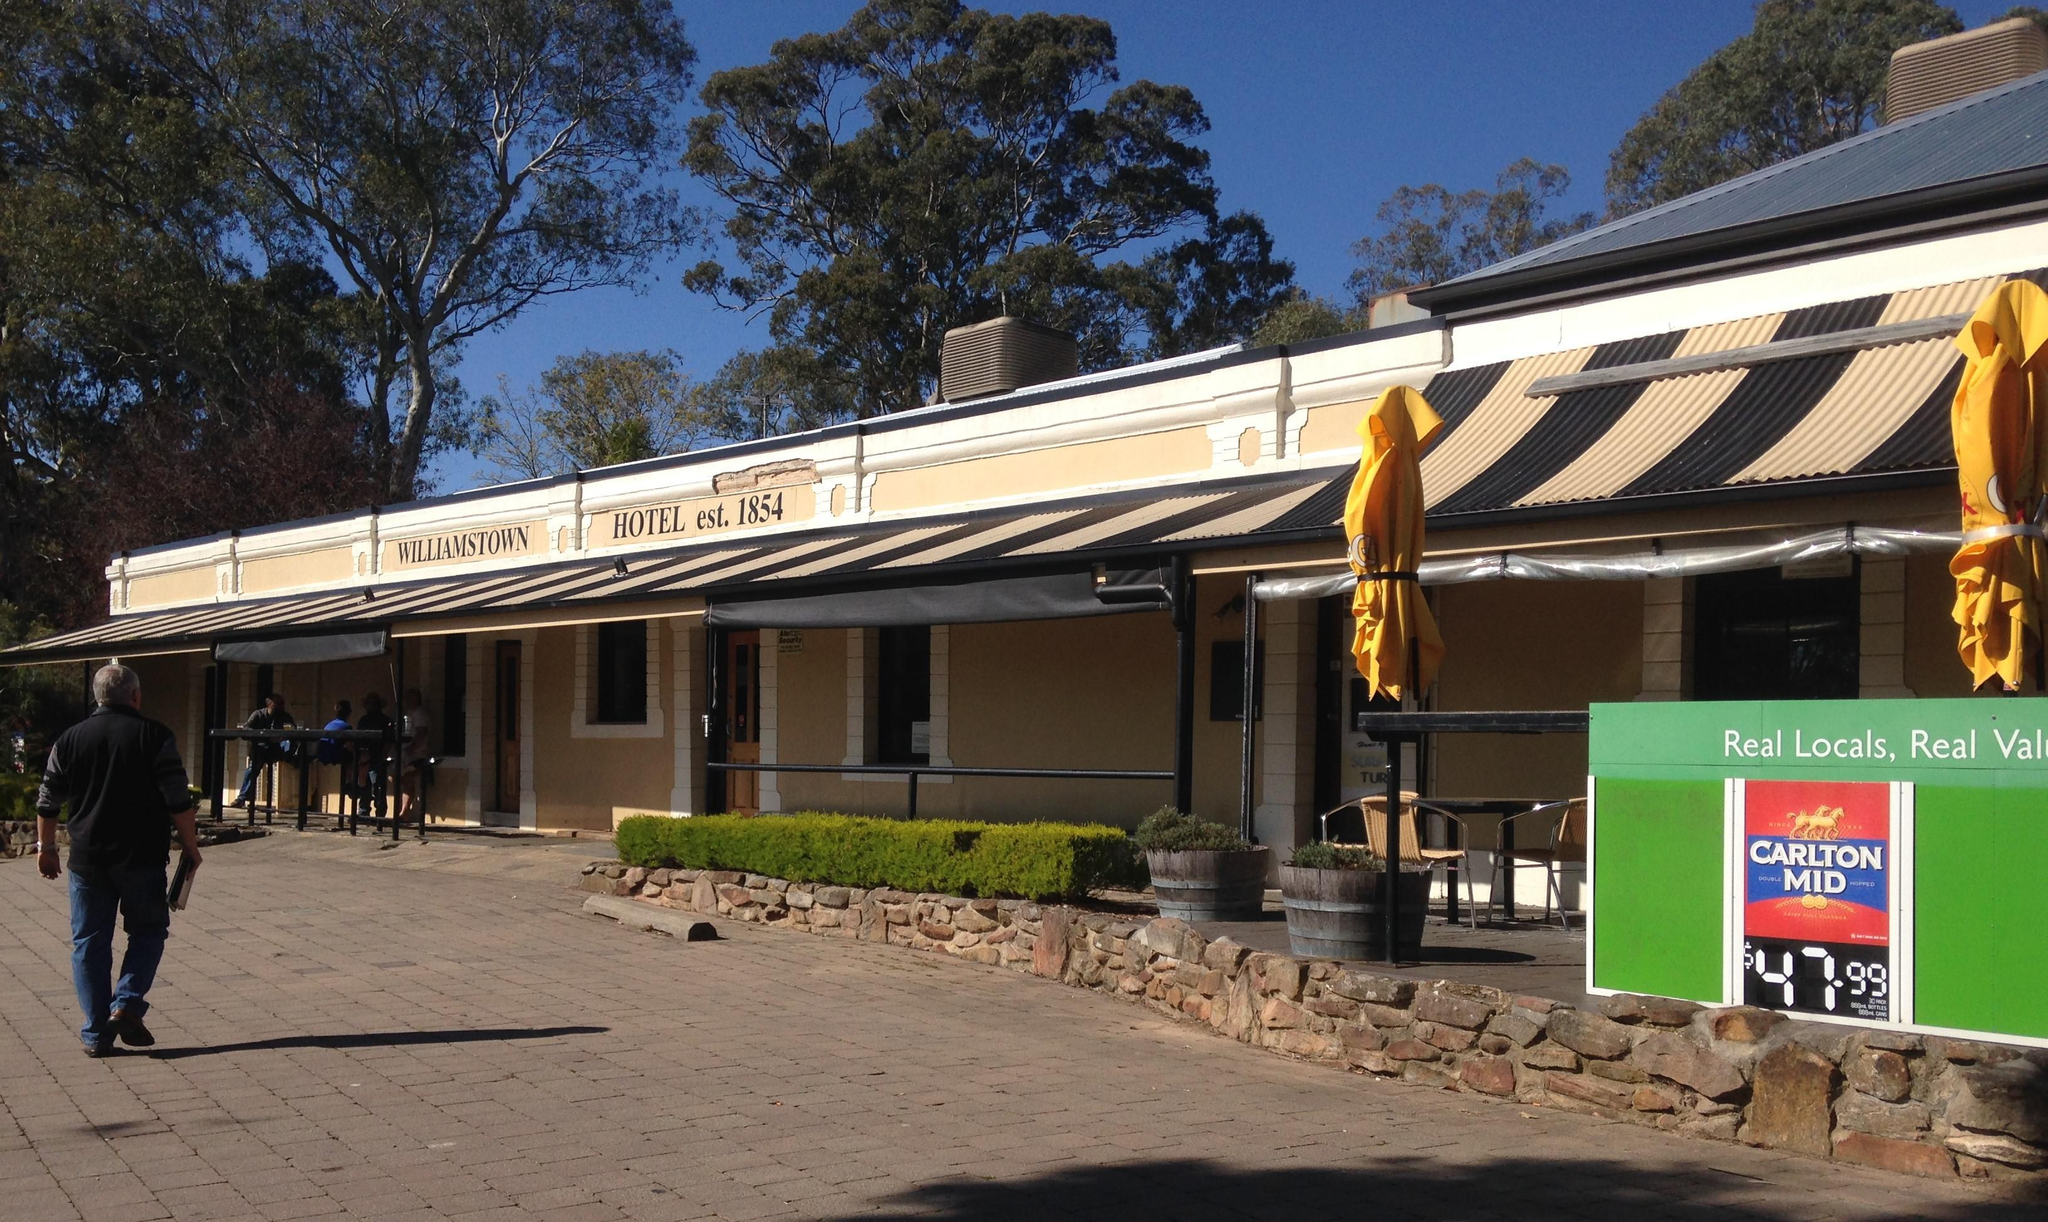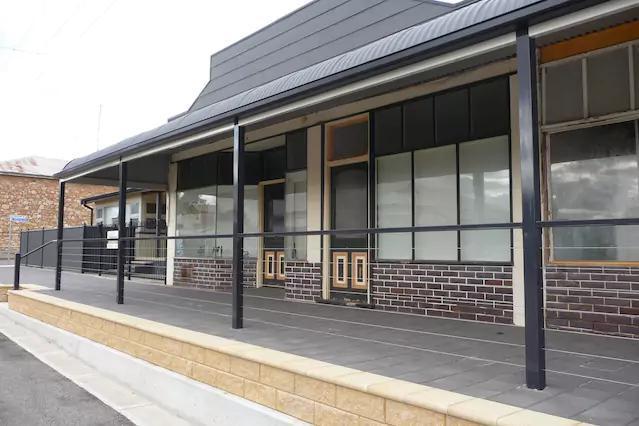The first image is the image on the left, the second image is the image on the right. Analyze the images presented: Is the assertion "A single person is outside of the shop in one of the images." valid? Answer yes or no. Yes. 